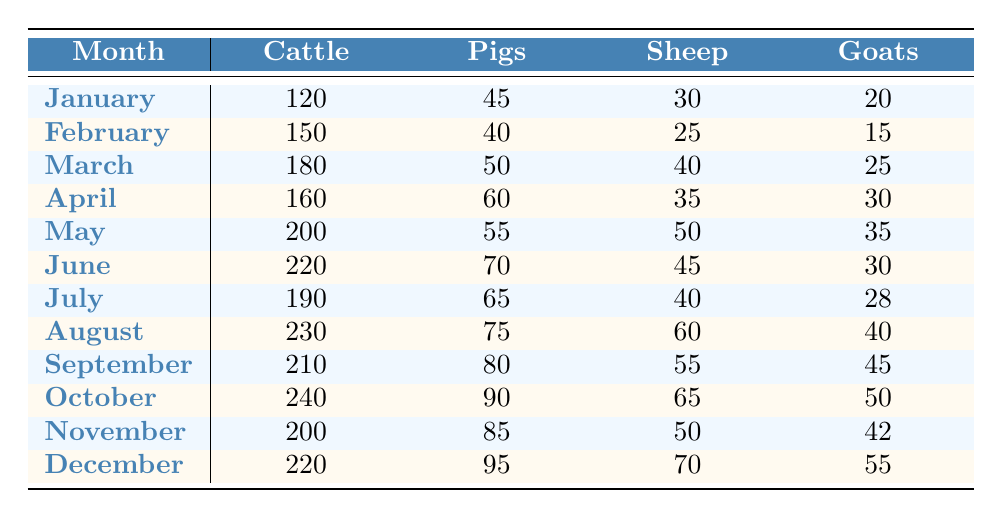What was the highest number of cattle sold in a month? Looking through the table, the highest value in the Cattle column is 240, which is found in October.
Answer: 240 Which month had the lowest goat sales? The lowest value in the Goats column is 15, which is recorded in February.
Answer: February How many sheep were sold in total from January to March? Adding the values from these months gives us 30 (January) + 40 (February) + 50 (March) = 120.
Answer: 120 Did more pigs or goats sell in August? In August, 75 pigs were sold and 40 goats were sold. Since 75 is greater than 40, more pigs were sold.
Answer: Yes What is the average number of pigs sold per month? To calculate the average, first sum the values for pigs: 45 + 40 + 50 + 60 + 55 + 70 + 65 + 75 + 80 + 90 + 85 + 95 =  855. There are 12 months, so divide 855 by 12 to get approximately 71.25.
Answer: 71.25 In which month were cattle and goats sold in equal numbers? Looking at both the Cattle and Goats columns, the only month where the values are the same is April, where 30 goats were sold as well as 160 cattle. This means they were not equal. Therefore, there is no month.
Answer: No How many more sheep were sold in October than in December? The number of sheep sold in October is 65, and in December is 70. So, 65 - 70 = -5, meaning 5 fewer sheep were sold in October than December.
Answer: 5 fewer What is the total number of livestock sold in January? To find the total, add all the livestock sold in January: 120 (Cattle) + 45 (Pigs) + 30 (Sheep) + 20 (Goats) = 215.
Answer: 215 Which month had the highest total livestock sales? First, we calculate total sales for each month. In August: 230 (Cattle) + 75 (Pigs) + 60 (Sheep) + 40 (Goats) = 405. Check all other months, and the highest total is indeed in August.
Answer: August 